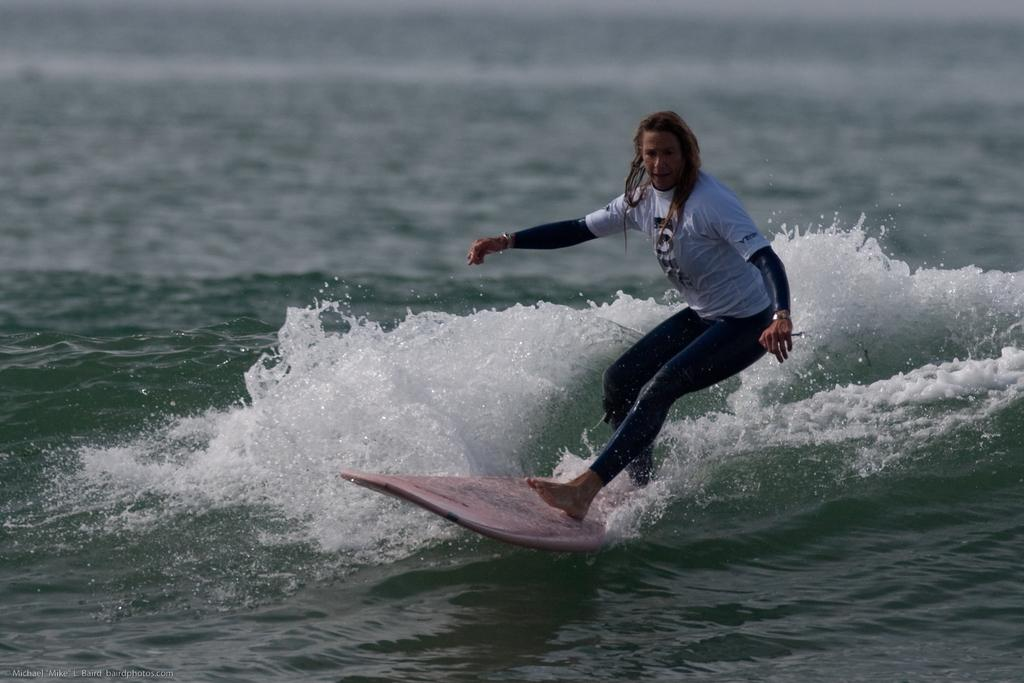What is the main subject of the image? There is a person in the image. What is the person doing in the image? The person is standing on a surfboard. Where is the person surfing in the image? The person is surfing on water. What type of jeans is the person wearing while surfing in the image? There is no information about the person's clothing in the image, so we cannot determine if they are wearing jeans or any other type of clothing. 